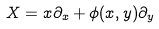<formula> <loc_0><loc_0><loc_500><loc_500>X = x \partial _ { x } + \phi ( x , y ) \partial _ { y }</formula> 